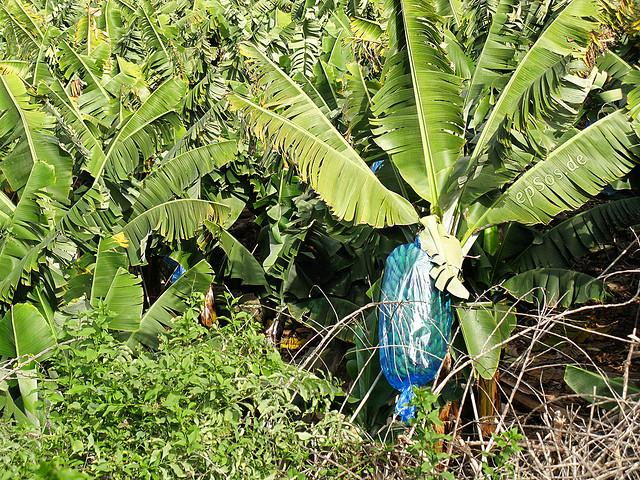What fruit is in the bright blue bag? Please explain your reasoning. bananas. There are bananas. 